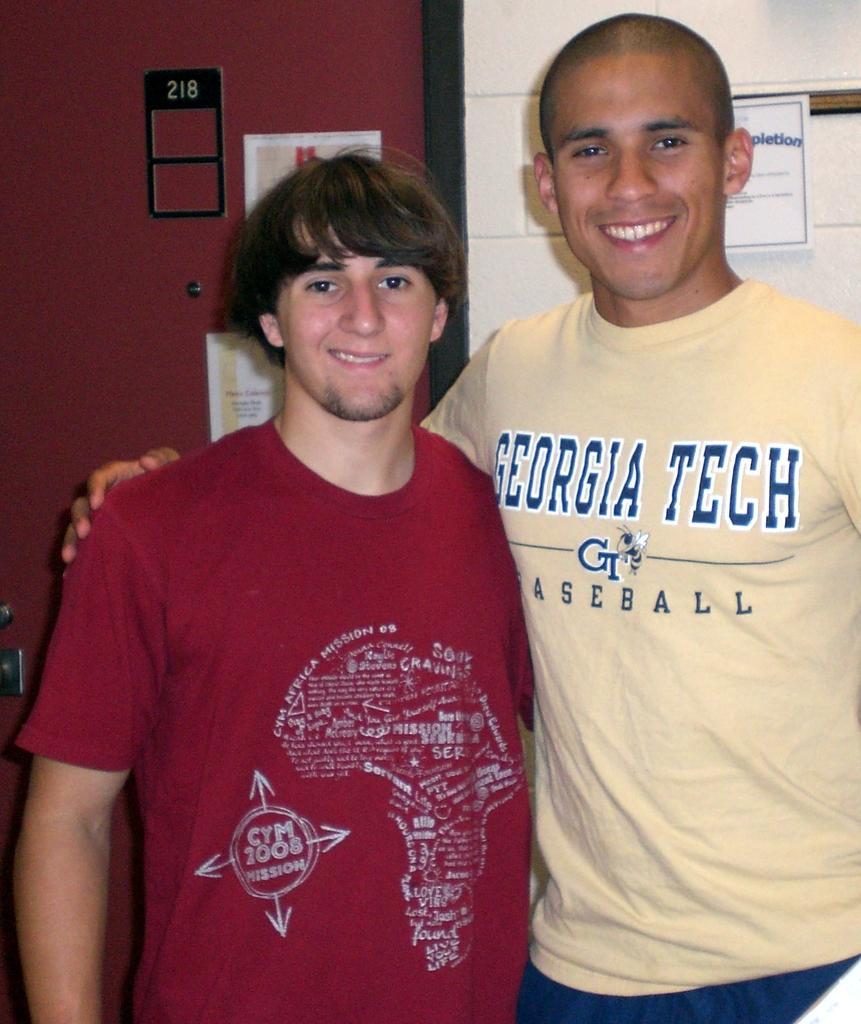Please provide a concise description of this image. In this image there are two persons standing as we can see in the middle of this image. There is a wall in the background. There are some posters attached on the wall as we can see on the top of this image. 